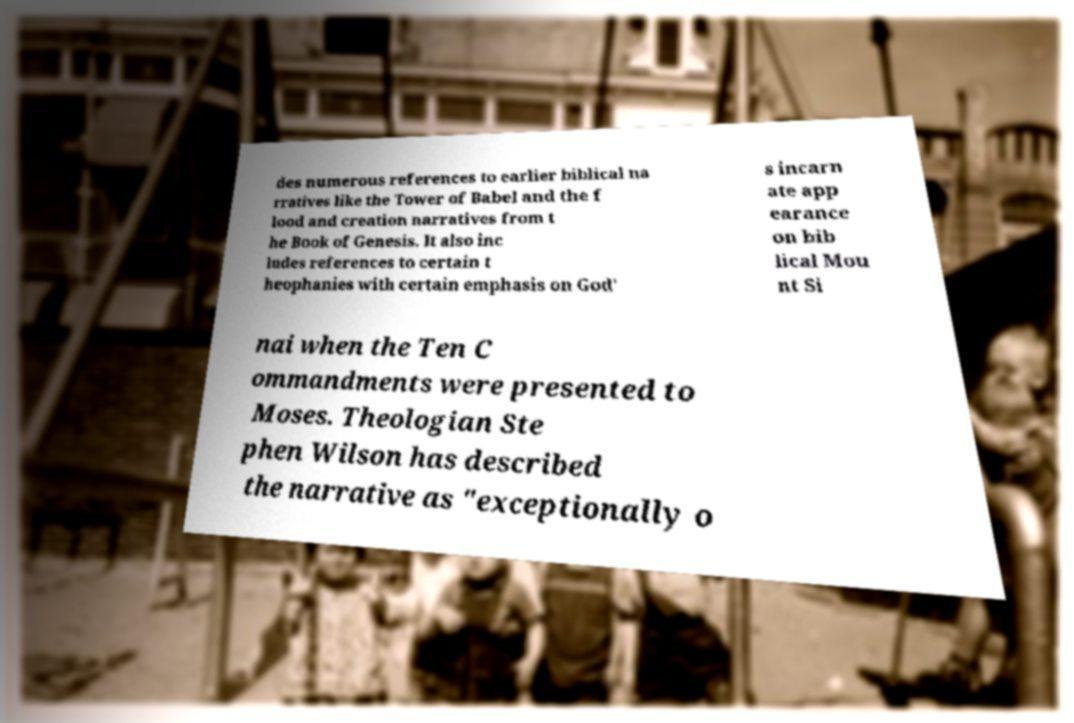Please identify and transcribe the text found in this image. des numerous references to earlier biblical na rratives like the Tower of Babel and the f lood and creation narratives from t he Book of Genesis. It also inc ludes references to certain t heophanies with certain emphasis on God' s incarn ate app earance on bib lical Mou nt Si nai when the Ten C ommandments were presented to Moses. Theologian Ste phen Wilson has described the narrative as "exceptionally o 